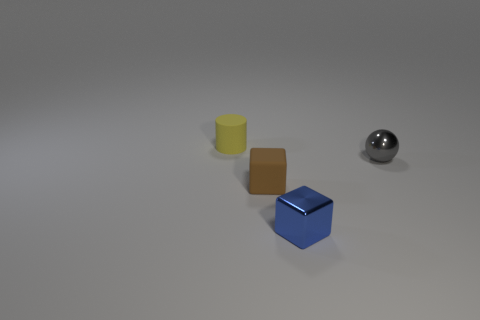Does the brown rubber block have the same size as the blue metal cube?
Give a very brief answer. Yes. How many cubes are the same size as the gray ball?
Your answer should be very brief. 2. Do the cube to the left of the tiny blue metal cube and the tiny object that is to the right of the small metallic block have the same material?
Your answer should be compact. No. Is there anything else that has the same shape as the gray shiny object?
Ensure brevity in your answer.  No. What color is the small shiny sphere?
Provide a succinct answer. Gray. What number of other tiny metallic objects have the same shape as the yellow object?
Provide a succinct answer. 0. The matte cylinder that is the same size as the blue thing is what color?
Make the answer very short. Yellow. Are any small things visible?
Offer a very short reply. Yes. There is a object in front of the small brown cube; what is its shape?
Offer a terse response. Cube. What number of matte objects are behind the gray metallic thing and in front of the small gray shiny object?
Keep it short and to the point. 0. 